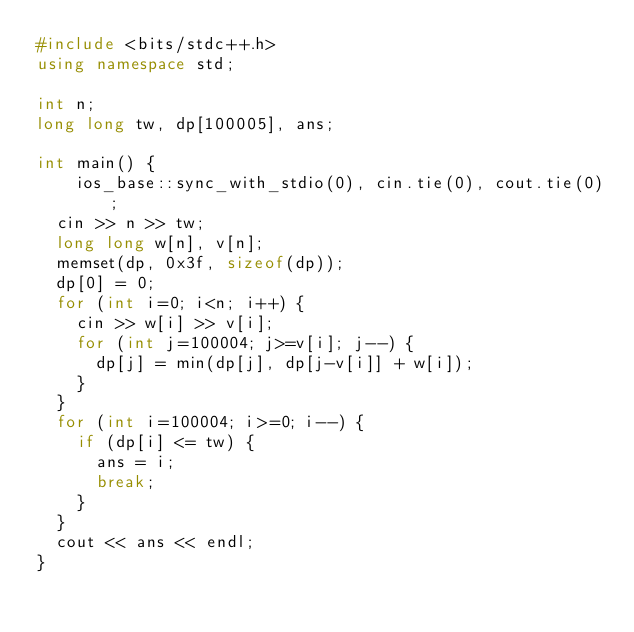<code> <loc_0><loc_0><loc_500><loc_500><_C++_>#include <bits/stdc++.h>
using namespace std;

int n;
long long tw, dp[100005], ans;

int main() {
    ios_base::sync_with_stdio(0), cin.tie(0), cout.tie(0);
	cin >> n >> tw;
	long long w[n], v[n];
	memset(dp, 0x3f, sizeof(dp));
	dp[0] = 0;
	for (int i=0; i<n; i++) {
		cin >> w[i] >> v[i];
		for (int j=100004; j>=v[i]; j--) {
			dp[j] = min(dp[j], dp[j-v[i]] + w[i]);
		}
	}
	for (int i=100004; i>=0; i--) {
		if (dp[i] <= tw) {
			ans = i;
			break;
		}
	}
	cout << ans << endl;
}</code> 